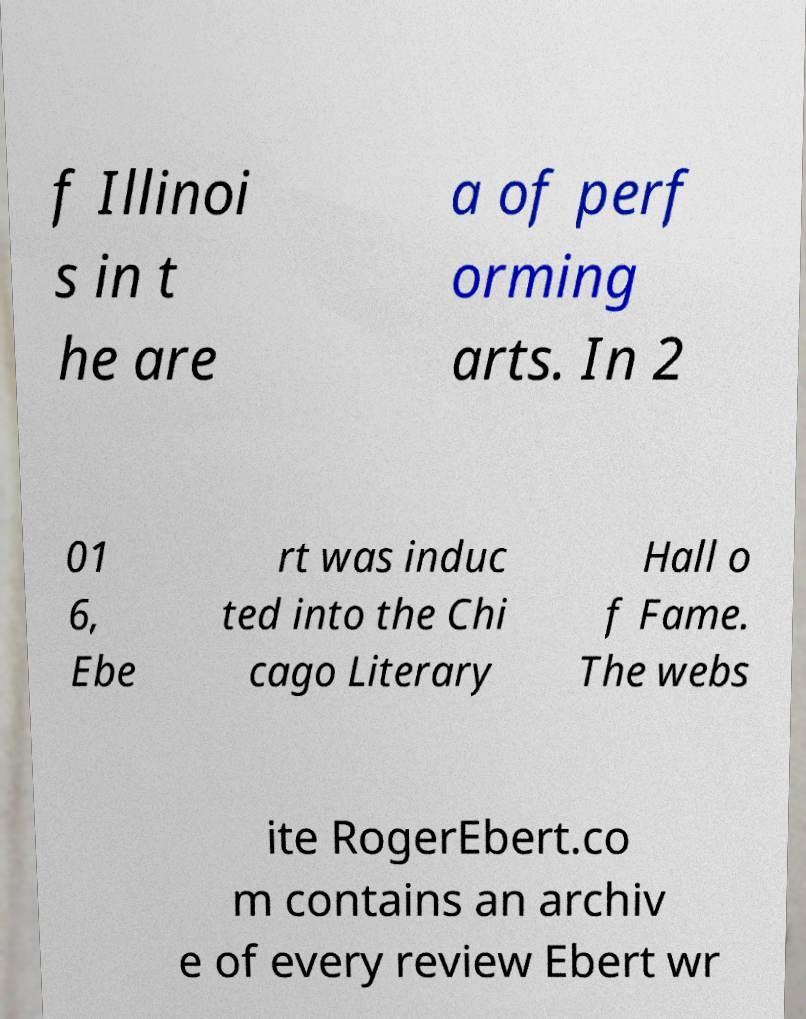Please read and relay the text visible in this image. What does it say? f Illinoi s in t he are a of perf orming arts. In 2 01 6, Ebe rt was induc ted into the Chi cago Literary Hall o f Fame. The webs ite RogerEbert.co m contains an archiv e of every review Ebert wr 